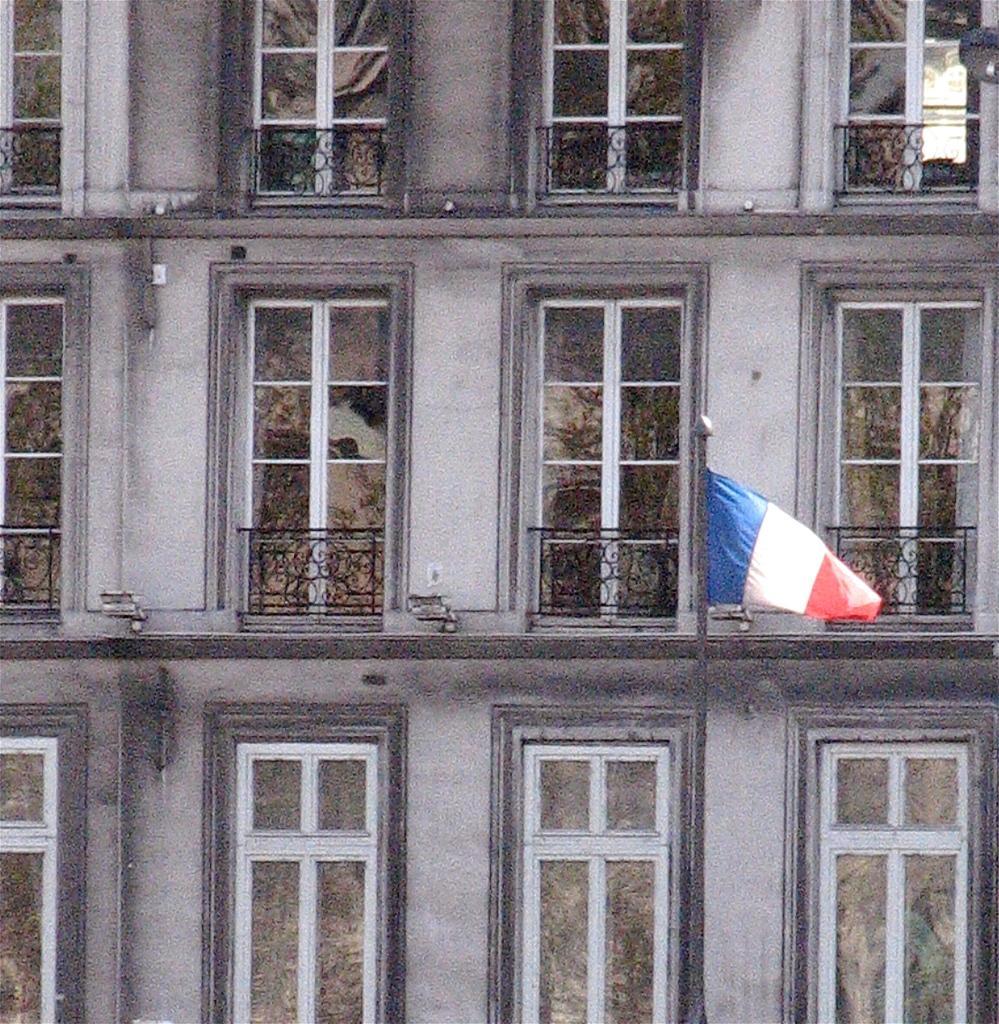Could you give a brief overview of what you see in this image? In this image we can see a building, flag, flag post, windows and grills. 